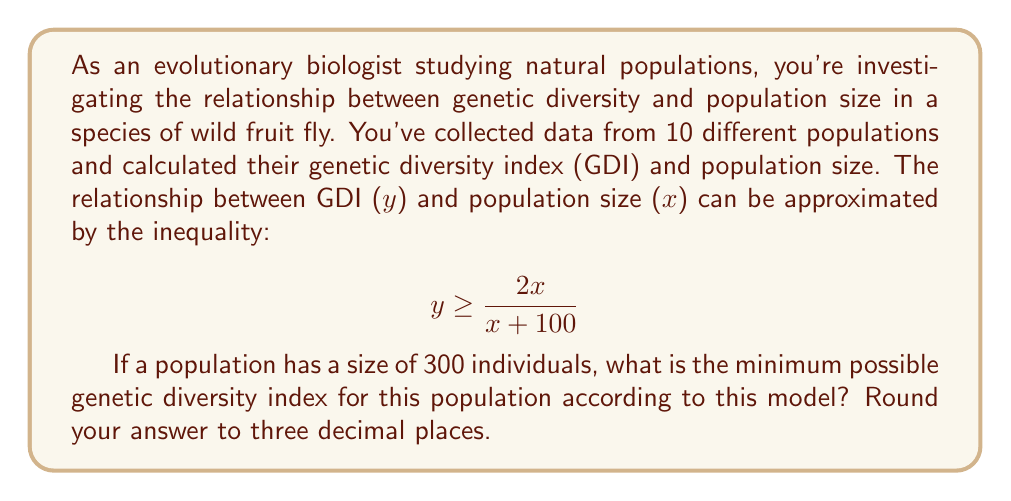Can you answer this question? To solve this problem, we need to follow these steps:

1) We're given the inequality:
   $$ y \geq \frac{2x}{x + 100} $$

2) We're asked to find the minimum possible value of y when x = 300. The minimum value will occur when the inequality is an equality:
   $$ y = \frac{2x}{x + 100} $$

3) Substitute x = 300 into this equation:
   $$ y = \frac{2(300)}{300 + 100} $$

4) Simplify the numerator:
   $$ y = \frac{600}{300 + 100} $$

5) Simplify the denominator:
   $$ y = \frac{600}{400} $$

6) Divide:
   $$ y = 1.5 $$

7) Rounding to three decimal places:
   $$ y \approx 1.500 $$

This result suggests that for a population of 300 individuals, the genetic diversity index must be at least 1.500 according to this model.
Answer: 1.500 